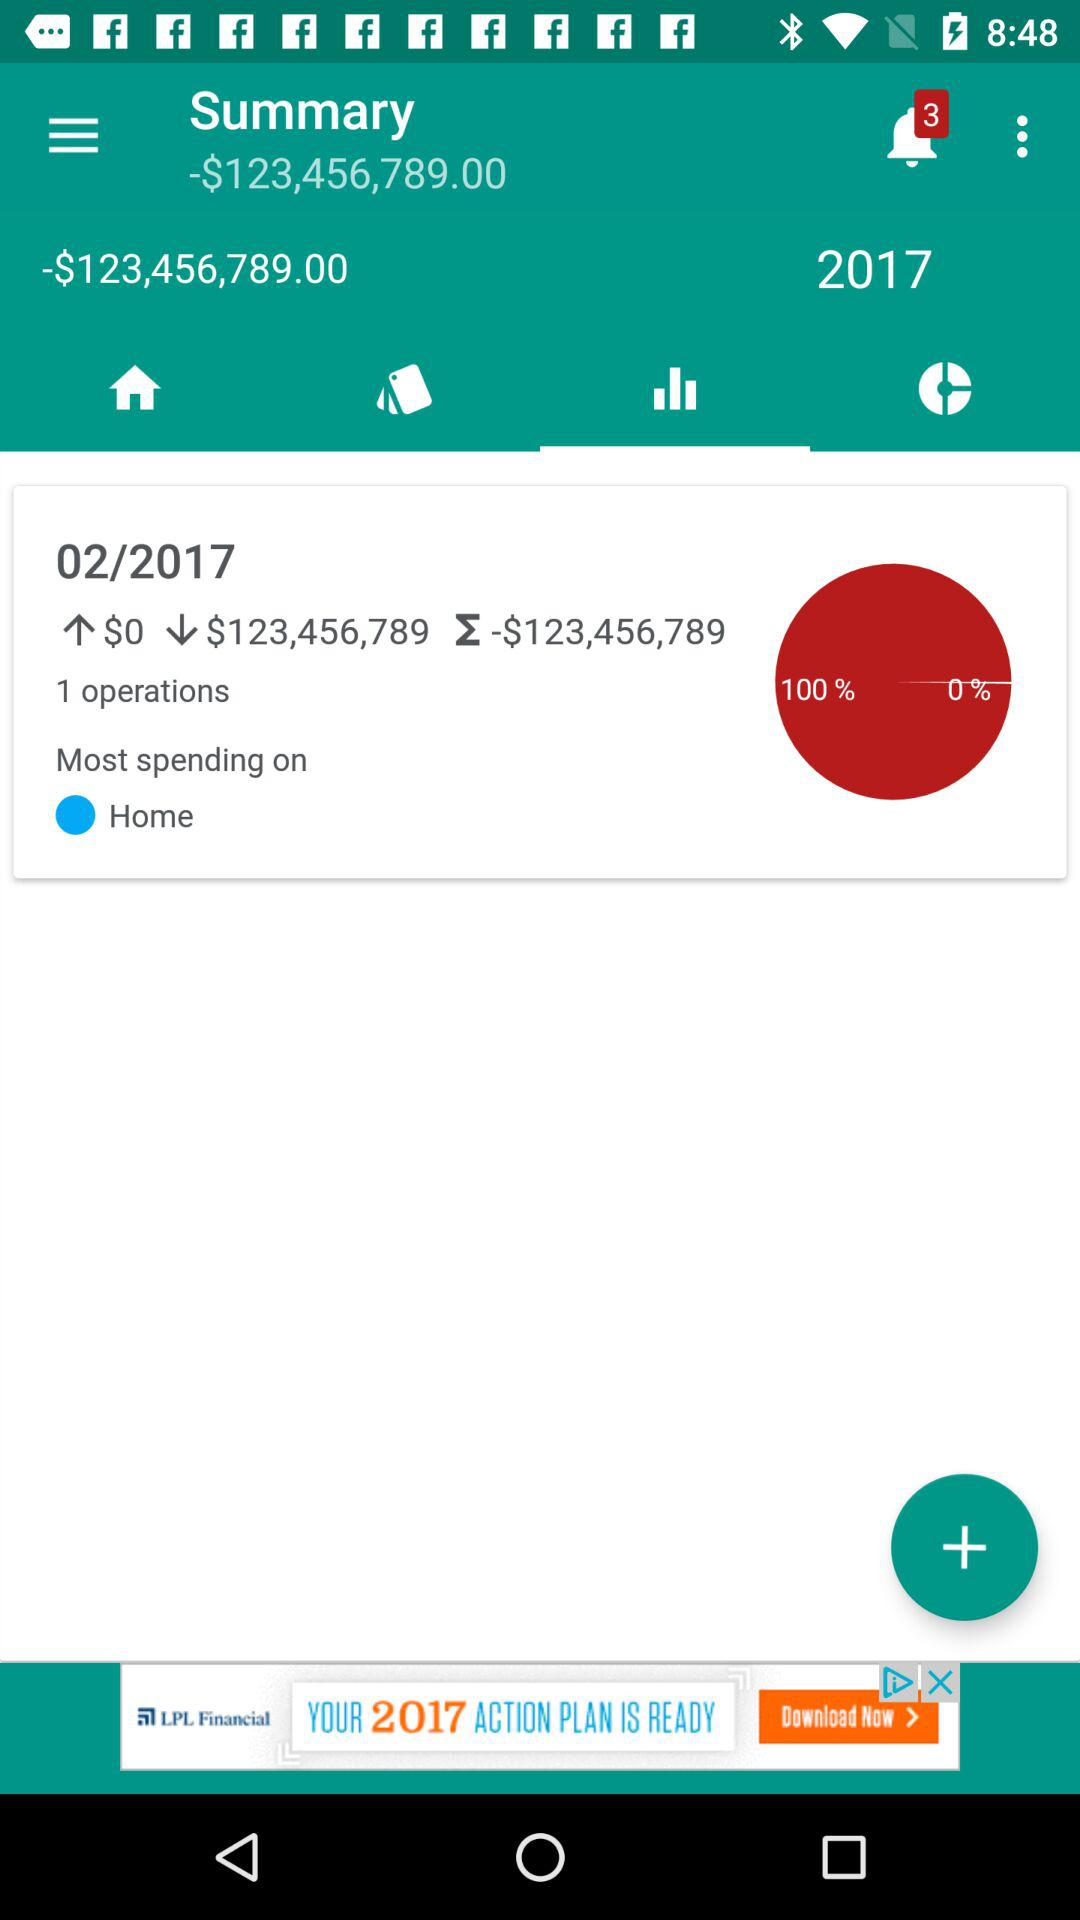What is the percentage of spending that is on home?
Answer the question using a single word or phrase. 100% 